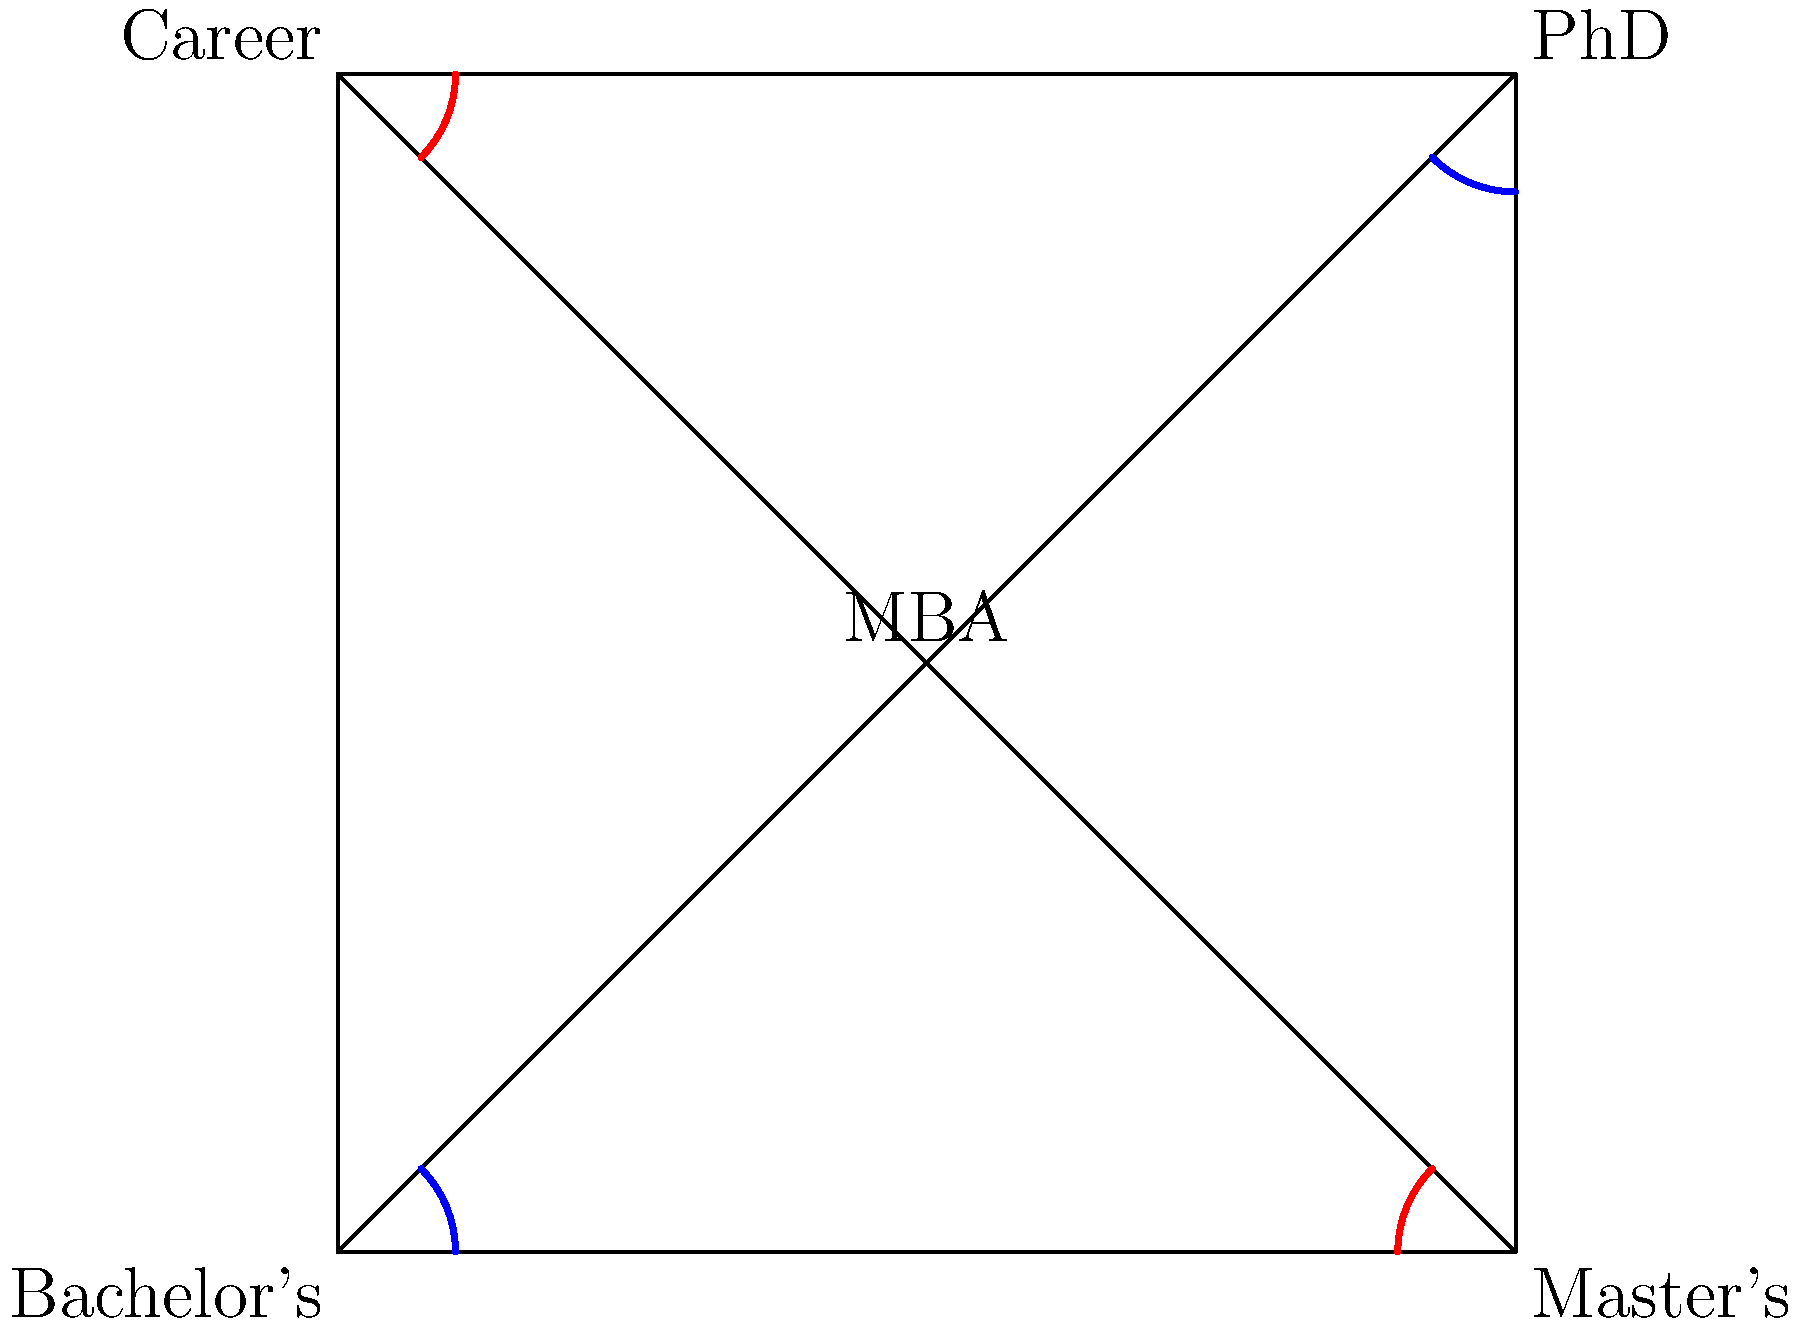In the flowchart depicting a traditional career progression, which two pairs of angles are congruent, and what does this congruence signify about the relationship between different educational and career stages? To answer this question, let's analyze the flowchart step-by-step:

1. The flowchart is in the shape of a square, representing four key stages: Bachelor's, Master's, PhD, and Career.

2. The diagonal lines connecting opposite corners create four triangles, with the MBA stage at the center.

3. We can observe two pairs of congruent angles:
   a) The angles at the Bachelor's and PhD corners (marked in blue)
   b) The angles at the Master's and Career corners (marked in red)

4. These angles are congruent because:
   - In a square, all four corners are right angles (90°)
   - The diagonal lines bisect these right angles, creating 45° angles

5. The congruence of these angles signifies:
   a) The Bachelor's and PhD stages are symmetrical in terms of their relationship to the other stages
   b) The Master's and Career stages are also symmetrical in their relationship to the other stages

6. This symmetry in the flowchart implies:
   - A balanced progression through educational stages (Bachelor's to PhD)
   - An equal emphasis on advanced degrees (Master's) and practical experience (Career)
   - The MBA at the center suggests it can be pursued at various points in the progression

7. For a formally educated CEO of a tech company who prioritizes degrees and traditional paths to success, this congruence reinforces the idea that advanced education (PhD) and practical experience (Career) are equally important, with the MBA serving as a pivotal point in the progression.
Answer: Bachelor's-PhD and Master's-Career; balanced progression through education and career stages 